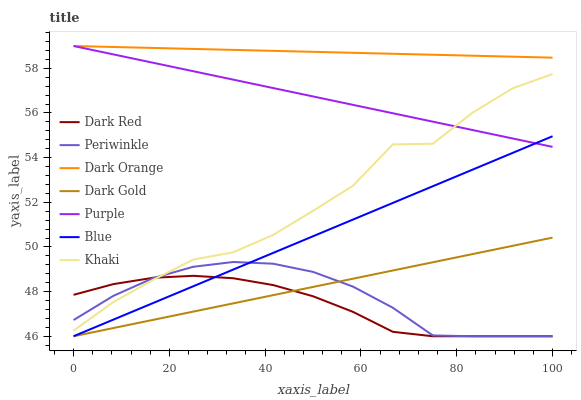Does Dark Red have the minimum area under the curve?
Answer yes or no. Yes. Does Dark Orange have the maximum area under the curve?
Answer yes or no. Yes. Does Khaki have the minimum area under the curve?
Answer yes or no. No. Does Khaki have the maximum area under the curve?
Answer yes or no. No. Is Dark Orange the smoothest?
Answer yes or no. Yes. Is Khaki the roughest?
Answer yes or no. Yes. Is Khaki the smoothest?
Answer yes or no. No. Is Dark Orange the roughest?
Answer yes or no. No. Does Blue have the lowest value?
Answer yes or no. Yes. Does Khaki have the lowest value?
Answer yes or no. No. Does Purple have the highest value?
Answer yes or no. Yes. Does Khaki have the highest value?
Answer yes or no. No. Is Dark Gold less than Purple?
Answer yes or no. Yes. Is Dark Orange greater than Blue?
Answer yes or no. Yes. Does Khaki intersect Purple?
Answer yes or no. Yes. Is Khaki less than Purple?
Answer yes or no. No. Is Khaki greater than Purple?
Answer yes or no. No. Does Dark Gold intersect Purple?
Answer yes or no. No. 